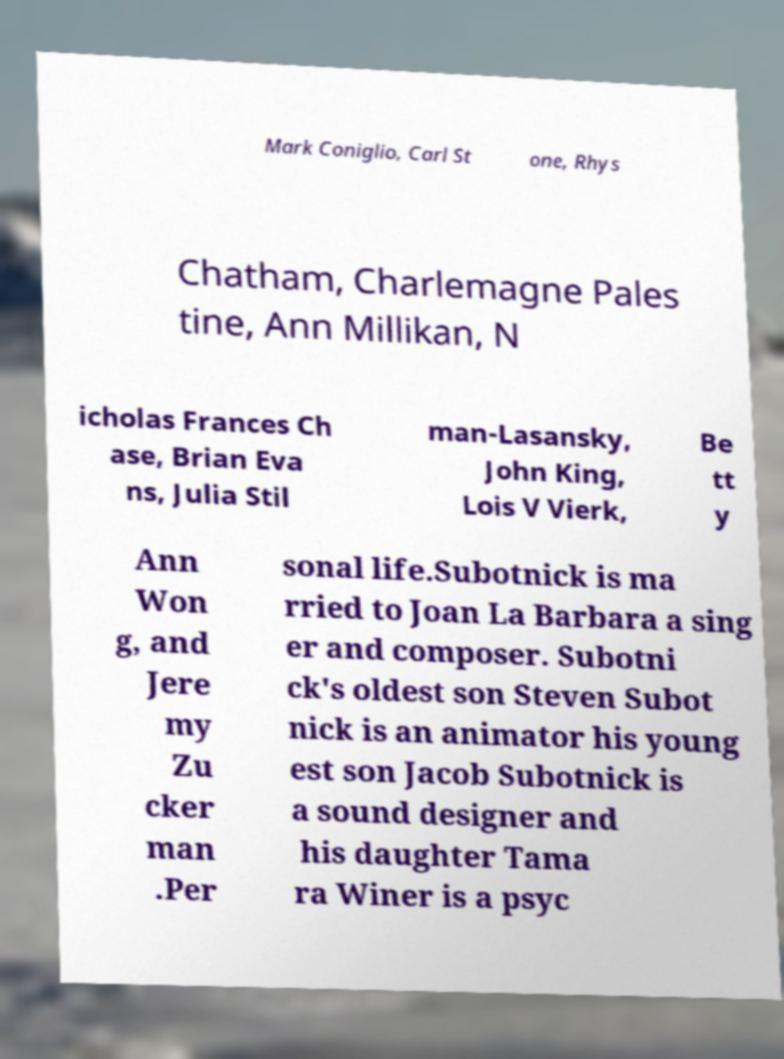Could you assist in decoding the text presented in this image and type it out clearly? Mark Coniglio, Carl St one, Rhys Chatham, Charlemagne Pales tine, Ann Millikan, N icholas Frances Ch ase, Brian Eva ns, Julia Stil man-Lasansky, John King, Lois V Vierk, Be tt y Ann Won g, and Jere my Zu cker man .Per sonal life.Subotnick is ma rried to Joan La Barbara a sing er and composer. Subotni ck's oldest son Steven Subot nick is an animator his young est son Jacob Subotnick is a sound designer and his daughter Tama ra Winer is a psyc 